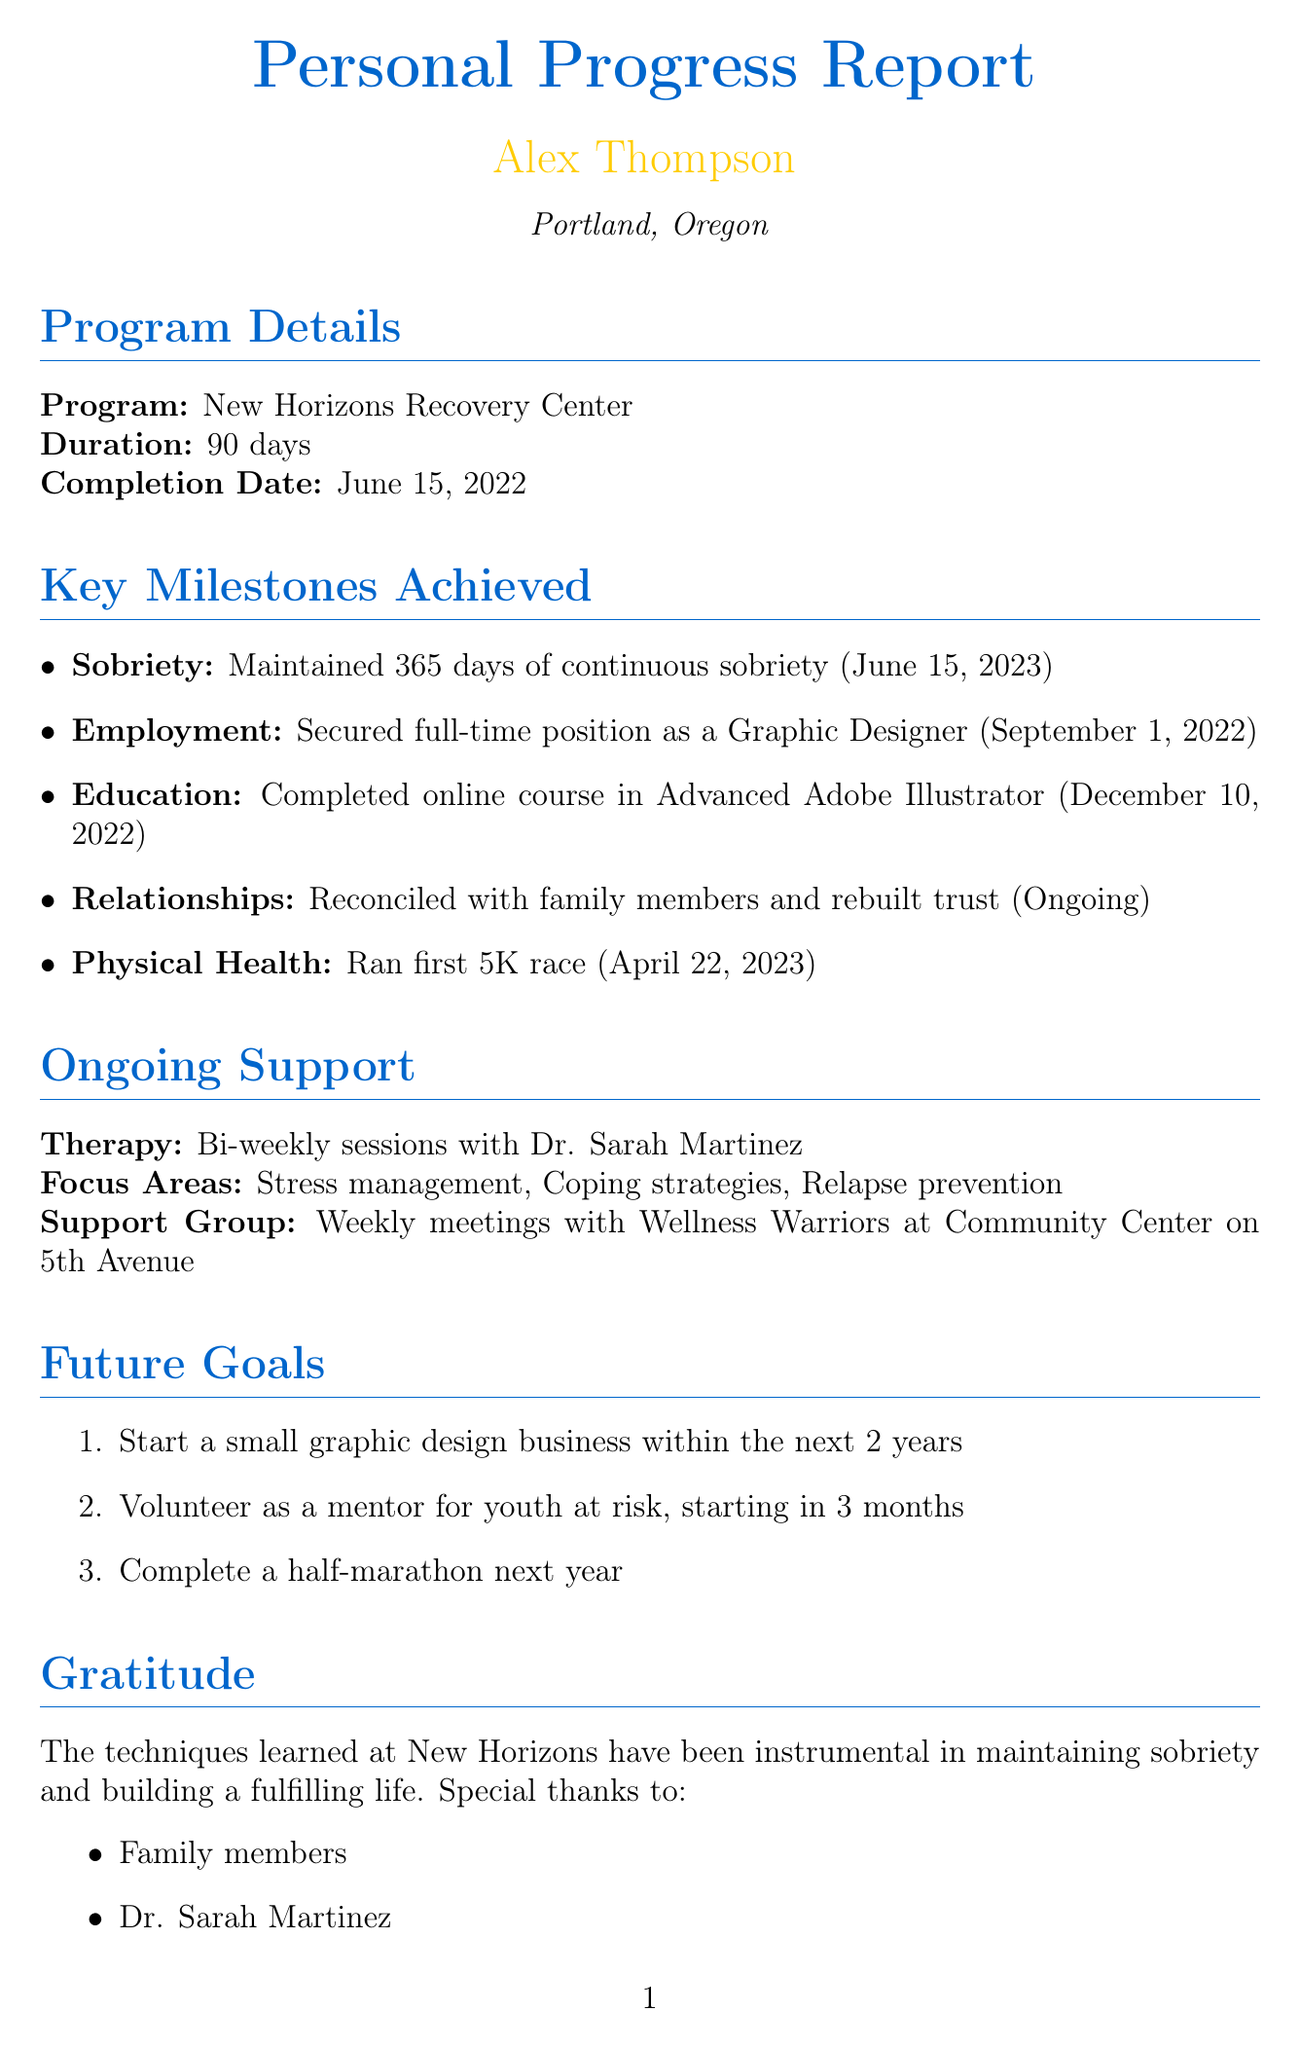What is the name of the rehabilitation program completed? The name of the rehabilitation program mentioned in the document is New Horizons Recovery Center.
Answer: New Horizons Recovery Center What was Alex's sobriety achievement date? The date associated with Alex's achievement of continuous sobriety is mentioned in the document.
Answer: June 15, 2023 How many days did the rehabilitation program last? The document specifies the duration of the rehabilitation program as a period of 90 days.
Answer: 90 days What is Alex's full-time employment position? The document indicates the specific job title that Alex secured after completing the program.
Answer: Graphic Designer What type of support group does Alex attend? The document specifies the name of the support group Alex is involved with after the program.
Answer: Wellness Warriors Which physical milestone did Alex achieve on April 22, 2023? The document details a specific fitness achievement that Alex completed on this date.
Answer: Ran first 5K race What is one of the focus areas of Alex's therapy? The document mentions multiple focus areas for ongoing therapy, highlighting one.
Answer: Stress management What is Alex's goal regarding volunteering? The document states a specific intention related to volunteering that Alex has for the future.
Answer: Mentor for youth at risk How often does Alex have therapy sessions? The document describes the frequency of Alex's therapeutic sessions post-rehabilitation.
Answer: Bi-weekly sessions 